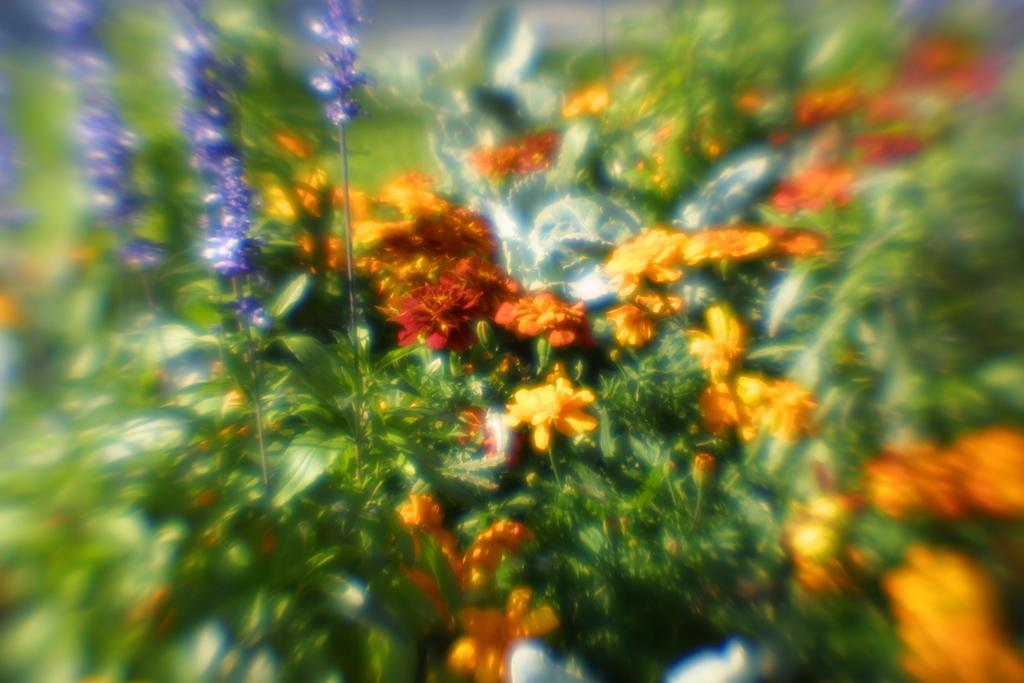Describe this image in one or two sentences. In the image I can see leaves and flowers. The given image is blurred. 